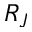Convert formula to latex. <formula><loc_0><loc_0><loc_500><loc_500>R _ { J }</formula> 